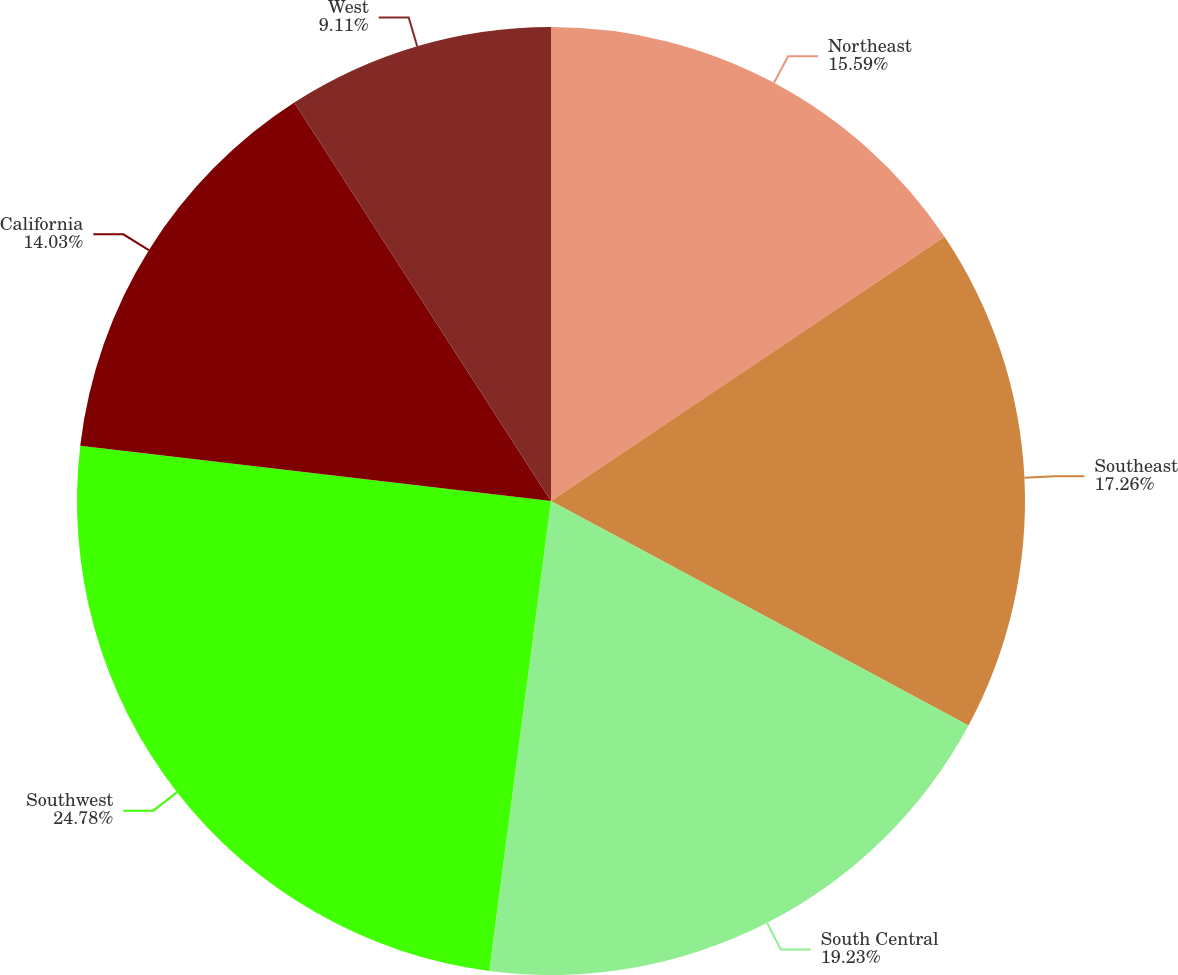Convert chart. <chart><loc_0><loc_0><loc_500><loc_500><pie_chart><fcel>Northeast<fcel>Southeast<fcel>South Central<fcel>Southwest<fcel>California<fcel>West<nl><fcel>15.59%<fcel>17.26%<fcel>19.23%<fcel>24.78%<fcel>14.03%<fcel>9.11%<nl></chart> 